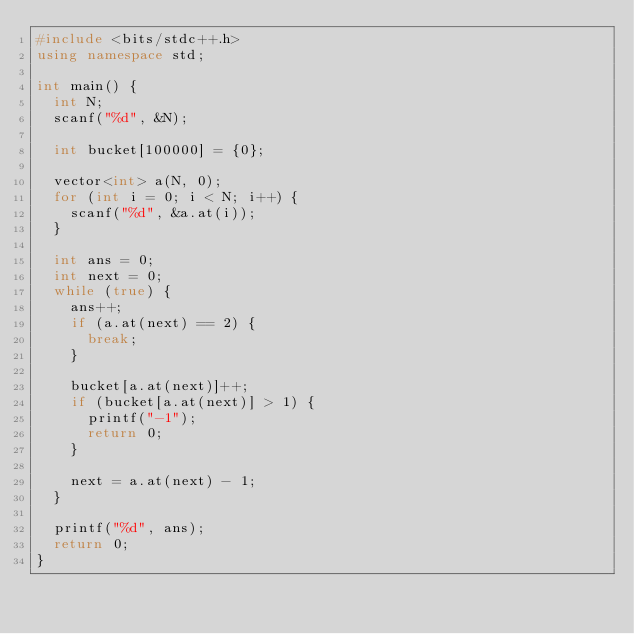<code> <loc_0><loc_0><loc_500><loc_500><_C++_>#include <bits/stdc++.h>
using namespace std;

int main() {
  int N;
  scanf("%d", &N);

  int bucket[100000] = {0};

  vector<int> a(N, 0);
  for (int i = 0; i < N; i++) {
    scanf("%d", &a.at(i));
  }

  int ans = 0;
  int next = 0;
  while (true) {
    ans++;
    if (a.at(next) == 2) {
      break;
    }
    
    bucket[a.at(next)]++;
    if (bucket[a.at(next)] > 1) {
      printf("-1");
      return 0;
    }
    
    next = a.at(next) - 1;
  }

  printf("%d", ans);
  return 0;
}</code> 